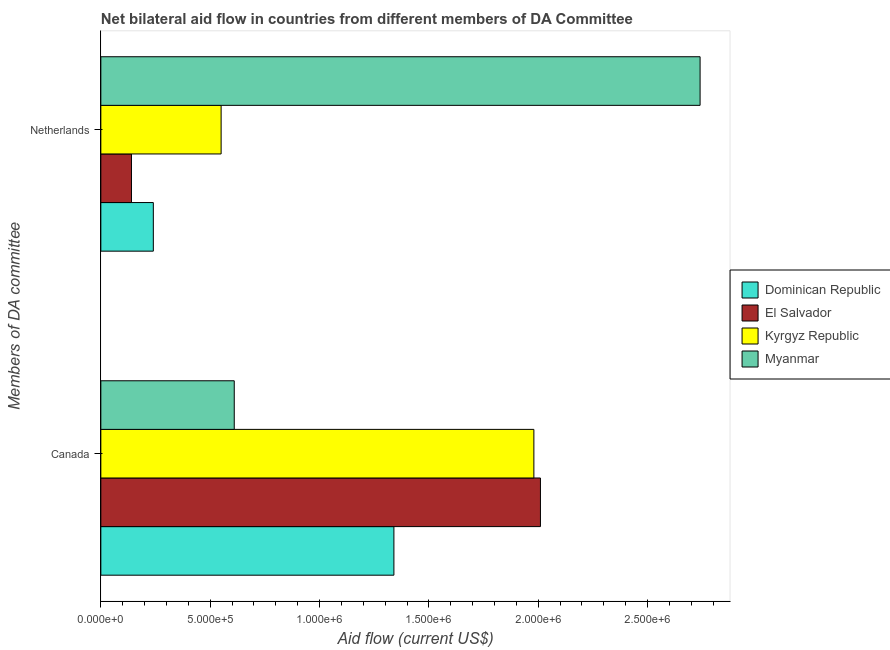How many bars are there on the 2nd tick from the bottom?
Provide a succinct answer. 4. What is the amount of aid given by canada in Myanmar?
Keep it short and to the point. 6.10e+05. Across all countries, what is the maximum amount of aid given by netherlands?
Your response must be concise. 2.74e+06. Across all countries, what is the minimum amount of aid given by netherlands?
Your response must be concise. 1.40e+05. In which country was the amount of aid given by canada maximum?
Offer a terse response. El Salvador. In which country was the amount of aid given by canada minimum?
Your answer should be very brief. Myanmar. What is the total amount of aid given by netherlands in the graph?
Provide a succinct answer. 3.67e+06. What is the difference between the amount of aid given by netherlands in Myanmar and that in Kyrgyz Republic?
Your response must be concise. 2.19e+06. What is the difference between the amount of aid given by netherlands in Kyrgyz Republic and the amount of aid given by canada in Dominican Republic?
Offer a very short reply. -7.90e+05. What is the average amount of aid given by canada per country?
Offer a terse response. 1.48e+06. What is the difference between the amount of aid given by netherlands and amount of aid given by canada in Kyrgyz Republic?
Give a very brief answer. -1.43e+06. In how many countries, is the amount of aid given by canada greater than 800000 US$?
Your response must be concise. 3. What is the ratio of the amount of aid given by canada in Dominican Republic to that in El Salvador?
Ensure brevity in your answer.  0.67. Is the amount of aid given by canada in Myanmar less than that in Dominican Republic?
Keep it short and to the point. Yes. In how many countries, is the amount of aid given by canada greater than the average amount of aid given by canada taken over all countries?
Offer a terse response. 2. What does the 2nd bar from the top in Canada represents?
Your answer should be compact. Kyrgyz Republic. What does the 1st bar from the bottom in Canada represents?
Keep it short and to the point. Dominican Republic. Are the values on the major ticks of X-axis written in scientific E-notation?
Offer a very short reply. Yes. Does the graph contain any zero values?
Your response must be concise. No. Does the graph contain grids?
Your answer should be compact. No. How many legend labels are there?
Ensure brevity in your answer.  4. How are the legend labels stacked?
Make the answer very short. Vertical. What is the title of the graph?
Give a very brief answer. Net bilateral aid flow in countries from different members of DA Committee. What is the label or title of the X-axis?
Give a very brief answer. Aid flow (current US$). What is the label or title of the Y-axis?
Ensure brevity in your answer.  Members of DA committee. What is the Aid flow (current US$) in Dominican Republic in Canada?
Your answer should be compact. 1.34e+06. What is the Aid flow (current US$) in El Salvador in Canada?
Offer a very short reply. 2.01e+06. What is the Aid flow (current US$) in Kyrgyz Republic in Canada?
Your answer should be very brief. 1.98e+06. What is the Aid flow (current US$) in Kyrgyz Republic in Netherlands?
Offer a very short reply. 5.50e+05. What is the Aid flow (current US$) in Myanmar in Netherlands?
Provide a succinct answer. 2.74e+06. Across all Members of DA committee, what is the maximum Aid flow (current US$) in Dominican Republic?
Give a very brief answer. 1.34e+06. Across all Members of DA committee, what is the maximum Aid flow (current US$) of El Salvador?
Give a very brief answer. 2.01e+06. Across all Members of DA committee, what is the maximum Aid flow (current US$) of Kyrgyz Republic?
Make the answer very short. 1.98e+06. Across all Members of DA committee, what is the maximum Aid flow (current US$) of Myanmar?
Offer a very short reply. 2.74e+06. Across all Members of DA committee, what is the minimum Aid flow (current US$) in Kyrgyz Republic?
Your answer should be compact. 5.50e+05. Across all Members of DA committee, what is the minimum Aid flow (current US$) of Myanmar?
Offer a terse response. 6.10e+05. What is the total Aid flow (current US$) in Dominican Republic in the graph?
Your answer should be very brief. 1.58e+06. What is the total Aid flow (current US$) in El Salvador in the graph?
Your answer should be very brief. 2.15e+06. What is the total Aid flow (current US$) in Kyrgyz Republic in the graph?
Keep it short and to the point. 2.53e+06. What is the total Aid flow (current US$) in Myanmar in the graph?
Your answer should be very brief. 3.35e+06. What is the difference between the Aid flow (current US$) of Dominican Republic in Canada and that in Netherlands?
Give a very brief answer. 1.10e+06. What is the difference between the Aid flow (current US$) in El Salvador in Canada and that in Netherlands?
Provide a succinct answer. 1.87e+06. What is the difference between the Aid flow (current US$) of Kyrgyz Republic in Canada and that in Netherlands?
Offer a very short reply. 1.43e+06. What is the difference between the Aid flow (current US$) in Myanmar in Canada and that in Netherlands?
Ensure brevity in your answer.  -2.13e+06. What is the difference between the Aid flow (current US$) in Dominican Republic in Canada and the Aid flow (current US$) in El Salvador in Netherlands?
Provide a succinct answer. 1.20e+06. What is the difference between the Aid flow (current US$) in Dominican Republic in Canada and the Aid flow (current US$) in Kyrgyz Republic in Netherlands?
Your answer should be compact. 7.90e+05. What is the difference between the Aid flow (current US$) of Dominican Republic in Canada and the Aid flow (current US$) of Myanmar in Netherlands?
Ensure brevity in your answer.  -1.40e+06. What is the difference between the Aid flow (current US$) in El Salvador in Canada and the Aid flow (current US$) in Kyrgyz Republic in Netherlands?
Make the answer very short. 1.46e+06. What is the difference between the Aid flow (current US$) of El Salvador in Canada and the Aid flow (current US$) of Myanmar in Netherlands?
Give a very brief answer. -7.30e+05. What is the difference between the Aid flow (current US$) in Kyrgyz Republic in Canada and the Aid flow (current US$) in Myanmar in Netherlands?
Make the answer very short. -7.60e+05. What is the average Aid flow (current US$) of Dominican Republic per Members of DA committee?
Your answer should be very brief. 7.90e+05. What is the average Aid flow (current US$) of El Salvador per Members of DA committee?
Provide a succinct answer. 1.08e+06. What is the average Aid flow (current US$) in Kyrgyz Republic per Members of DA committee?
Provide a succinct answer. 1.26e+06. What is the average Aid flow (current US$) of Myanmar per Members of DA committee?
Offer a terse response. 1.68e+06. What is the difference between the Aid flow (current US$) in Dominican Republic and Aid flow (current US$) in El Salvador in Canada?
Offer a very short reply. -6.70e+05. What is the difference between the Aid flow (current US$) of Dominican Republic and Aid flow (current US$) of Kyrgyz Republic in Canada?
Offer a very short reply. -6.40e+05. What is the difference between the Aid flow (current US$) of Dominican Republic and Aid flow (current US$) of Myanmar in Canada?
Make the answer very short. 7.30e+05. What is the difference between the Aid flow (current US$) of El Salvador and Aid flow (current US$) of Kyrgyz Republic in Canada?
Make the answer very short. 3.00e+04. What is the difference between the Aid flow (current US$) in El Salvador and Aid flow (current US$) in Myanmar in Canada?
Your answer should be compact. 1.40e+06. What is the difference between the Aid flow (current US$) of Kyrgyz Republic and Aid flow (current US$) of Myanmar in Canada?
Give a very brief answer. 1.37e+06. What is the difference between the Aid flow (current US$) in Dominican Republic and Aid flow (current US$) in Kyrgyz Republic in Netherlands?
Ensure brevity in your answer.  -3.10e+05. What is the difference between the Aid flow (current US$) in Dominican Republic and Aid flow (current US$) in Myanmar in Netherlands?
Your answer should be very brief. -2.50e+06. What is the difference between the Aid flow (current US$) of El Salvador and Aid flow (current US$) of Kyrgyz Republic in Netherlands?
Your response must be concise. -4.10e+05. What is the difference between the Aid flow (current US$) of El Salvador and Aid flow (current US$) of Myanmar in Netherlands?
Ensure brevity in your answer.  -2.60e+06. What is the difference between the Aid flow (current US$) in Kyrgyz Republic and Aid flow (current US$) in Myanmar in Netherlands?
Your answer should be very brief. -2.19e+06. What is the ratio of the Aid flow (current US$) of Dominican Republic in Canada to that in Netherlands?
Give a very brief answer. 5.58. What is the ratio of the Aid flow (current US$) in El Salvador in Canada to that in Netherlands?
Provide a succinct answer. 14.36. What is the ratio of the Aid flow (current US$) of Myanmar in Canada to that in Netherlands?
Offer a terse response. 0.22. What is the difference between the highest and the second highest Aid flow (current US$) of Dominican Republic?
Ensure brevity in your answer.  1.10e+06. What is the difference between the highest and the second highest Aid flow (current US$) of El Salvador?
Your answer should be very brief. 1.87e+06. What is the difference between the highest and the second highest Aid flow (current US$) of Kyrgyz Republic?
Your response must be concise. 1.43e+06. What is the difference between the highest and the second highest Aid flow (current US$) in Myanmar?
Ensure brevity in your answer.  2.13e+06. What is the difference between the highest and the lowest Aid flow (current US$) in Dominican Republic?
Ensure brevity in your answer.  1.10e+06. What is the difference between the highest and the lowest Aid flow (current US$) of El Salvador?
Provide a succinct answer. 1.87e+06. What is the difference between the highest and the lowest Aid flow (current US$) of Kyrgyz Republic?
Offer a terse response. 1.43e+06. What is the difference between the highest and the lowest Aid flow (current US$) in Myanmar?
Your response must be concise. 2.13e+06. 